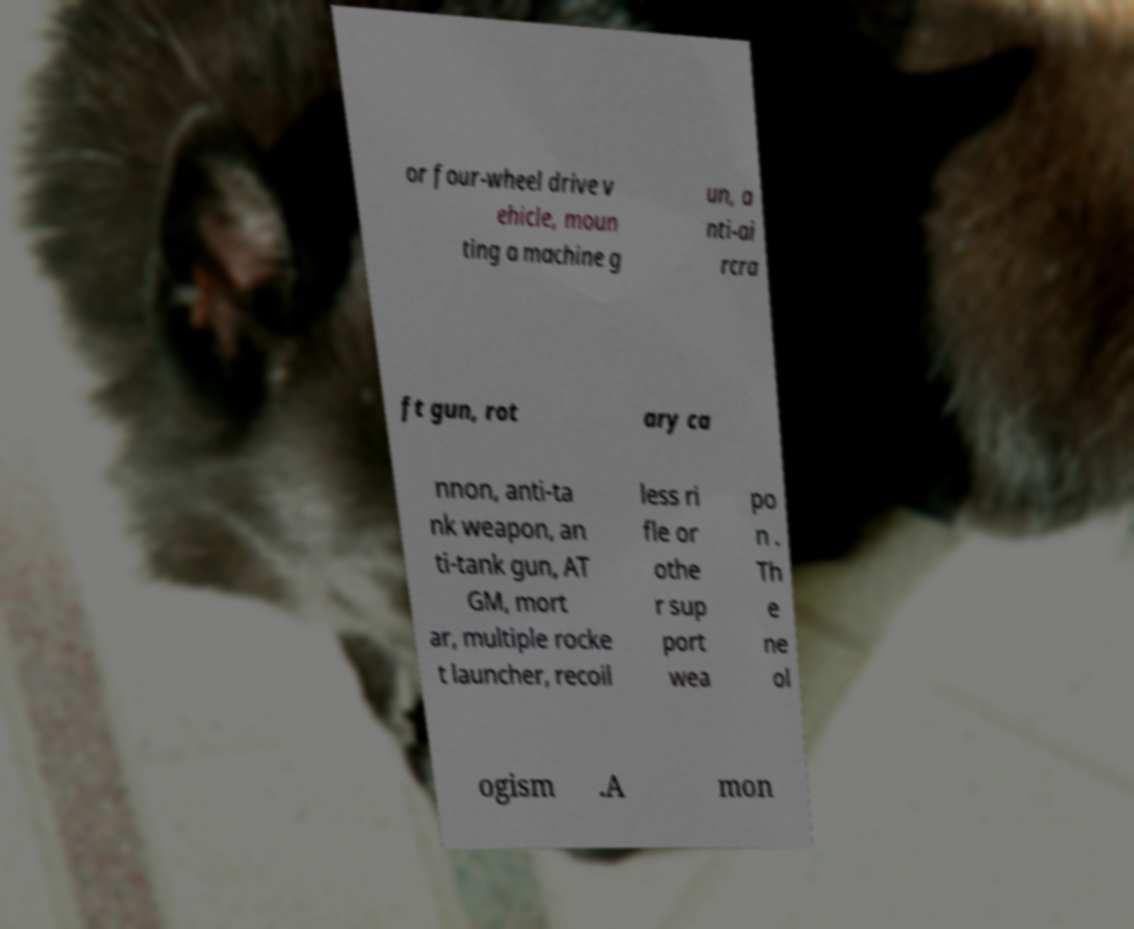Could you extract and type out the text from this image? or four-wheel drive v ehicle, moun ting a machine g un, a nti-ai rcra ft gun, rot ary ca nnon, anti-ta nk weapon, an ti-tank gun, AT GM, mort ar, multiple rocke t launcher, recoil less ri fle or othe r sup port wea po n . Th e ne ol ogism .A mon 